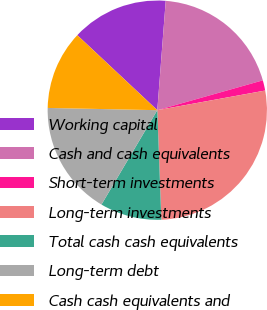Convert chart. <chart><loc_0><loc_0><loc_500><loc_500><pie_chart><fcel>Working capital<fcel>Cash and cash equivalents<fcel>Short-term investments<fcel>Long-term investments<fcel>Total cash cash equivalents<fcel>Long-term debt<fcel>Cash cash equivalents and<nl><fcel>14.24%<fcel>19.39%<fcel>1.52%<fcel>27.28%<fcel>9.09%<fcel>16.82%<fcel>11.66%<nl></chart> 